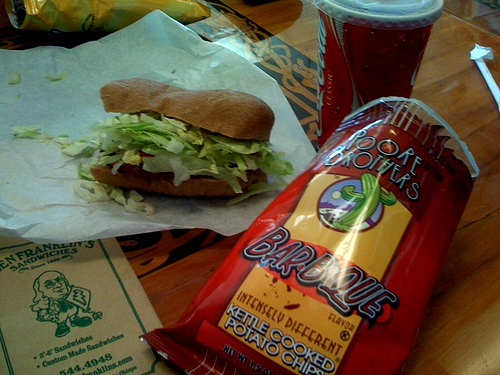How many cups? 1 